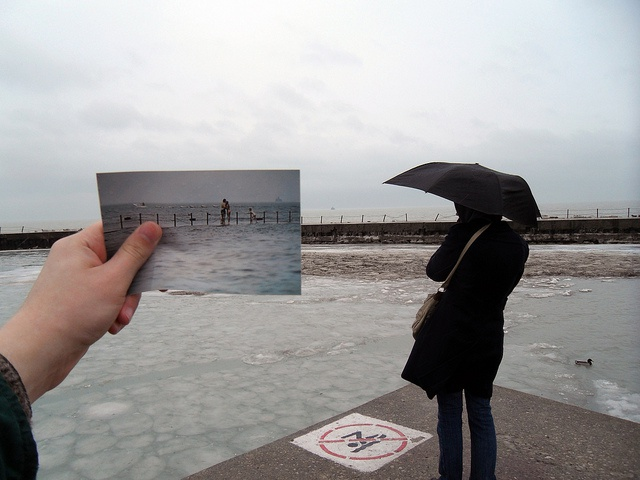Describe the objects in this image and their specific colors. I can see people in white, black, gray, and darkgray tones, people in white, gray, black, salmon, and darkgray tones, umbrella in white, black, and gray tones, handbag in white, black, gray, and maroon tones, and people in white, gray, and black tones in this image. 